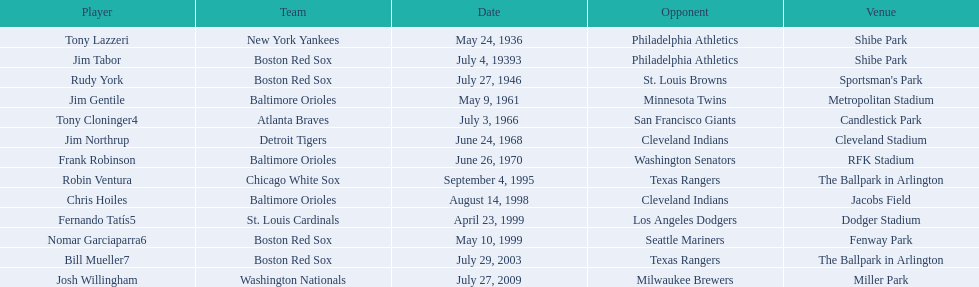What is the count of instances where a boston red sox player has hit two grand slams during one match? 4. 